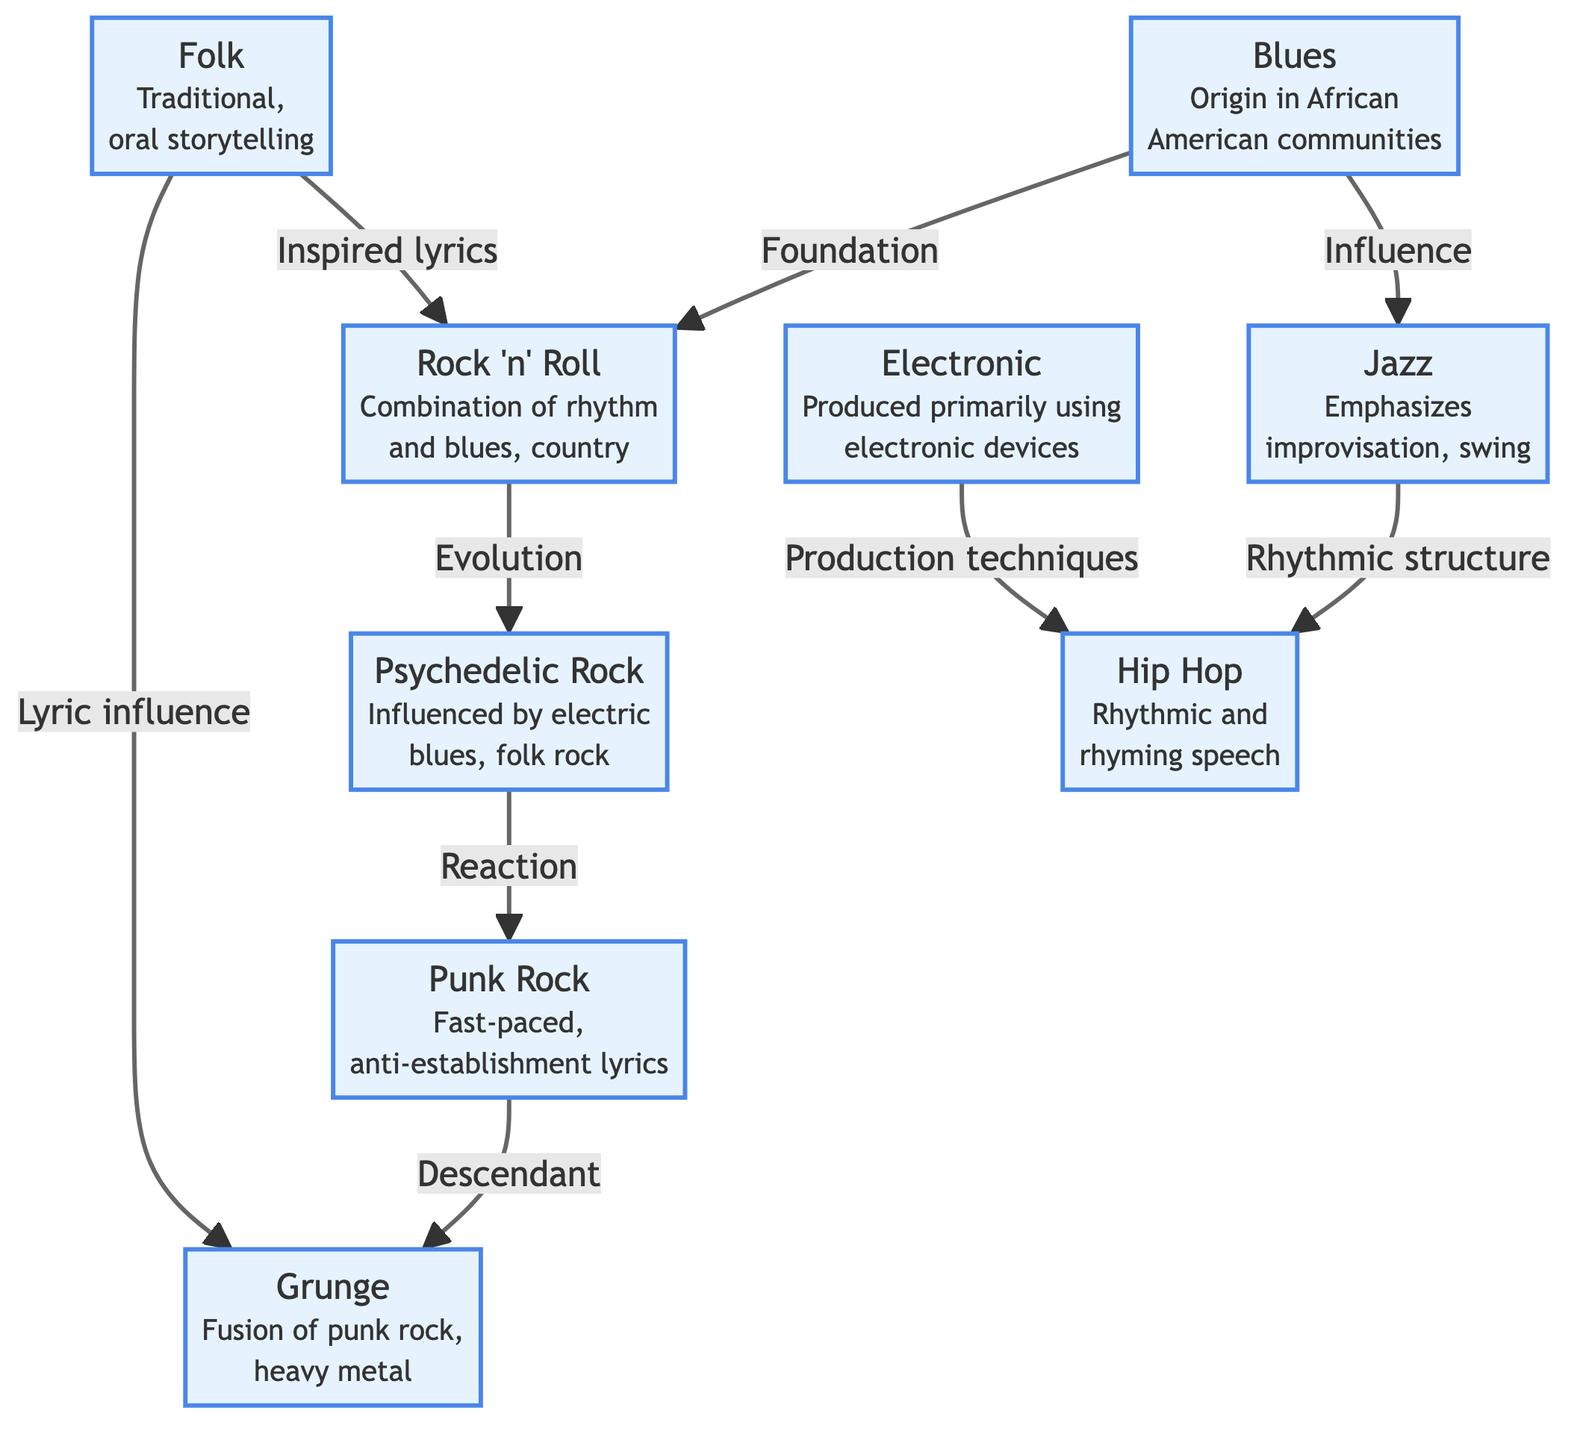What is the first genre listed in the diagram? The first genre in the diagram is located at the top and labeled as "Blues".
Answer: Blues Which genre is influenced by "Blues"? The diagram shows that "Jazz" is influenced by "Blues", as indicated by the arrow connecting them with the label "Influence".
Answer: Jazz How many genres are connected to "Rock 'n' Roll"? By examining the diagram, "Rock 'n' Roll" has two directly connected genres: "Blues" and "Folk", indicated by the arrows leading into "Rock 'n' Roll".
Answer: 2 What relationship does "Psychedelic Rock" have with "Punk Rock"? The relationship between "Psychedelic Rock" and "Punk Rock" is labeled as "Reaction", which shows how one genre reacts to the influence of the previous genre.
Answer: Reaction Which genre is a descendant of "Punk Rock"? According to the diagram, "Grunge" is labeled as a descendant of "Punk Rock", indicating a direct lineage of influence.
Answer: Grunge What two genres contribute to the structure of "Hip Hop"? The structure of "Hip Hop" is influenced by "Jazz" and "Electronic", as shown by the connecting arrows labeled accordingly.
Answer: Jazz and Electronic How many total genres are represented in the diagram? Counting all the nodes in the diagram, there are ten distinct genres represented throughout.
Answer: 10 What genre combines elements of "Punk Rock" and "Heavy Metal"? The diagram shows that "Grunge" is the genre resulting from the fusion of "Punk Rock" and "Heavy Metal", as indicated by the connections made in the flow.
Answer: Grunge Which genre emphasizes improvisation? The genre that emphasizes improvisation is labeled as "Jazz" in the diagram, as stated in its description.
Answer: Jazz 